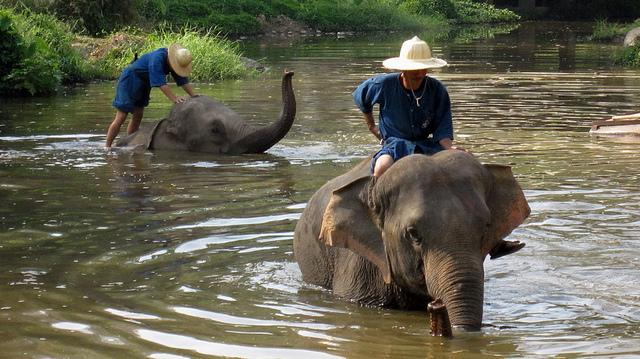What are the hats the men are wearing called?

Choices:
A) baseball caps
B) derby hats
C) safari hats
D) top hats safari hats 